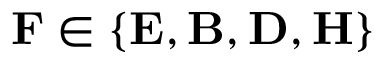Convert formula to latex. <formula><loc_0><loc_0><loc_500><loc_500>F \in \{ E , B , D , H \}</formula> 